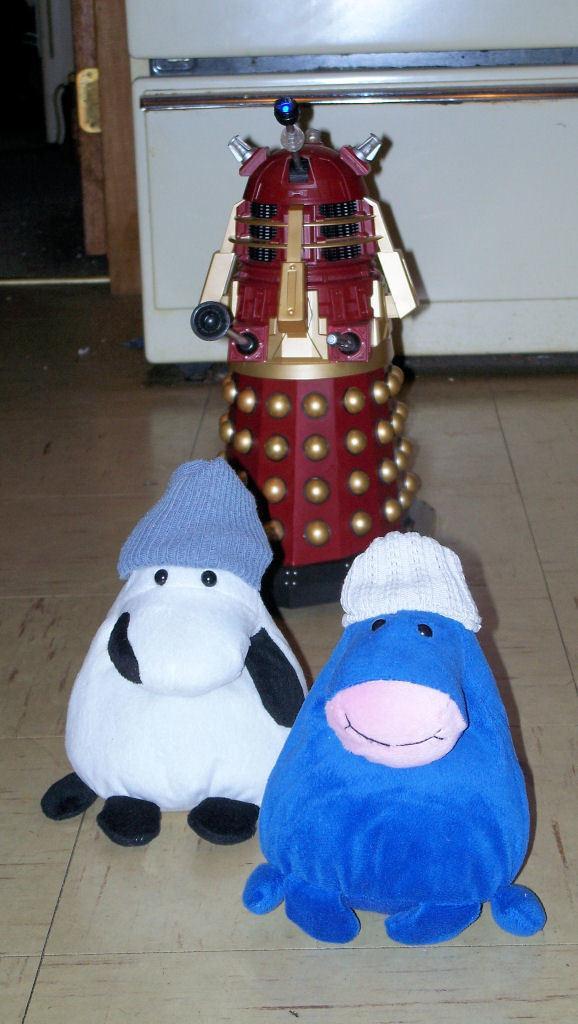Could you give a brief overview of what you see in this image? In this image I can see the white and blue color toys and the object in maroon, black and cream color. In the back I can see the white color object. 